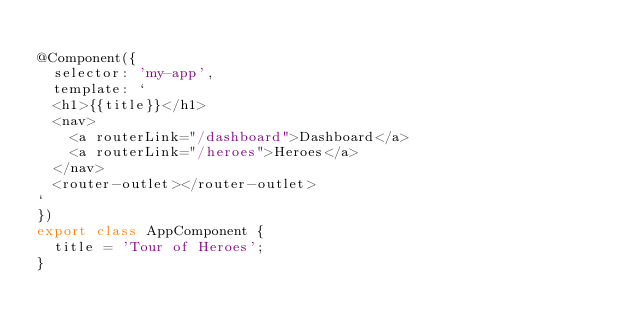<code> <loc_0><loc_0><loc_500><loc_500><_TypeScript_>
@Component({
  selector: 'my-app',
  template: `
  <h1>{{title}}</h1>
  <nav>
    <a routerLink="/dashboard">Dashboard</a>
    <a routerLink="/heroes">Heroes</a>
  </nav>
  <router-outlet></router-outlet>
`
})
export class AppComponent {
  title = 'Tour of Heroes';
}</code> 